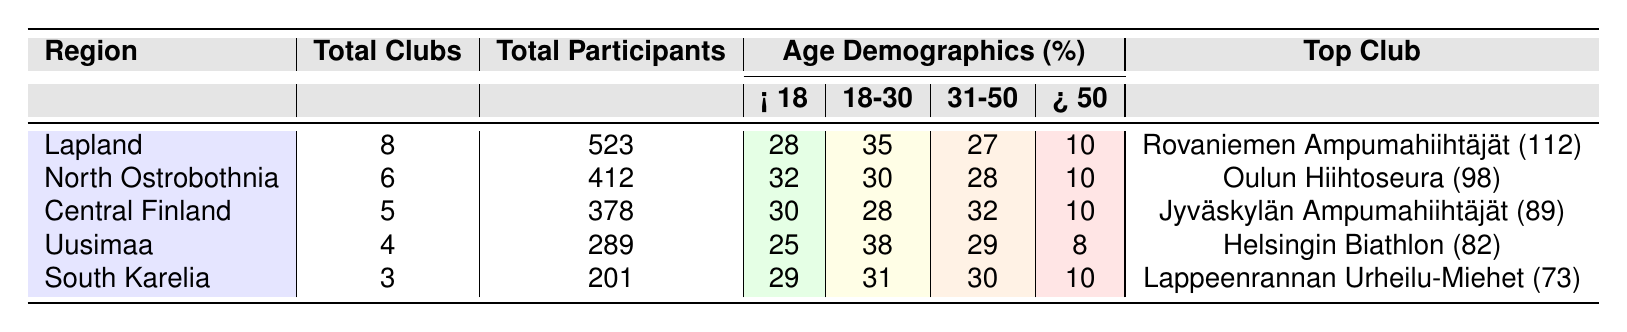What is the total number of clubs in Uusimaa? The table lists the total number of clubs specifically for each region, and Uusimaa has 4 total clubs.
Answer: 4 Which region has the highest percentage of participants aged 18-30? By examining the age demographics in the table, Uusimaa has the highest percentage of participants aged 18-30 at 38%.
Answer: 38% How many total participants are there in Lapland? The table shows that Lapland has a total of 523 participants.
Answer: 523 What is the average percentage of participants aged Over 50 across all regions? To calculate the average for Over 50, add the percentages from each region: (10 + 10 + 10 + 8 + 10) = 58, then divide by 5 (the number of regions): 58 / 5 = 11.6%.
Answer: 11.6% Is it true that Central Finland has more participants aged Under 18 than South Karelia? Checking the percentages, Central Finland has 30% Under 18 while South Karelia has 29% Under 18, hence this statement is true.
Answer: True Which region has the least number of total participants? Comparing the total participants across regions, South Karelia has the least with 201 participants.
Answer: 201 What is the difference in the number of total participants between North Ostrobothnia and Central Finland? North Ostrobothnia has 412 participants and Central Finland has 378. The difference is calculated as 412 - 378 = 34.
Answer: 34 Which club in Lapland has the highest number of members? The top club in Lapland is Rovaniemen Ampumahiihtäjät with 112 members, which is the highest among clubs in that region.
Answer: Rovaniemen Ampumahiihtäjät How many total participants are there in all regions combined? Adding the total participants from each region: 523 + 412 + 378 + 289 + 201 = 1803.
Answer: 1803 What is the percentage of participants aged 31-50 in North Ostrobothnia? The table indicates that North Ostrobothnia has 28% of its participants aged 31-50.
Answer: 28% 